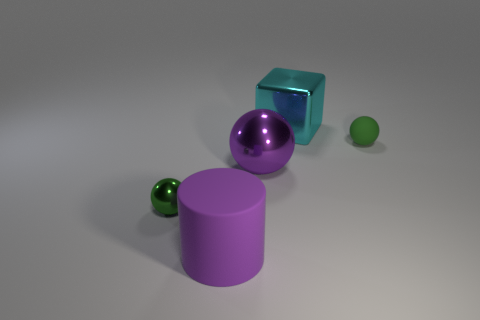Subtract all small balls. How many balls are left? 1 Subtract all purple spheres. How many spheres are left? 2 Subtract all yellow cylinders. How many green balls are left? 2 Subtract 1 spheres. How many spheres are left? 2 Add 4 small gray shiny things. How many objects exist? 9 Subtract all spheres. How many objects are left? 2 Subtract all blue balls. Subtract all gray blocks. How many balls are left? 3 Subtract all purple balls. Subtract all cyan cubes. How many objects are left? 3 Add 2 tiny green matte spheres. How many tiny green matte spheres are left? 3 Add 1 large green cylinders. How many large green cylinders exist? 1 